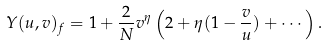Convert formula to latex. <formula><loc_0><loc_0><loc_500><loc_500>Y ( u , v ) _ { f } = 1 + \frac { 2 } { N } v ^ { \eta } \left ( 2 + \eta ( 1 - \frac { v } { u } ) + \cdots \right ) .</formula> 